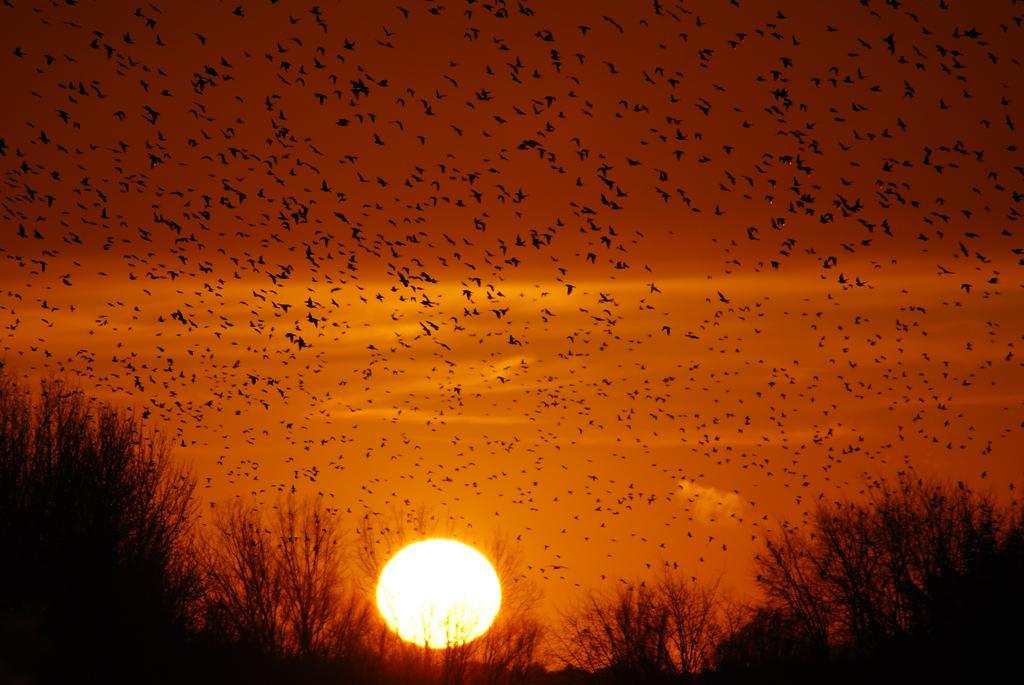Describe this image in one or two sentences. In this image I can see there are so many birds flying in the air I can see sun set at the bottom and I can see grass at the bottom 